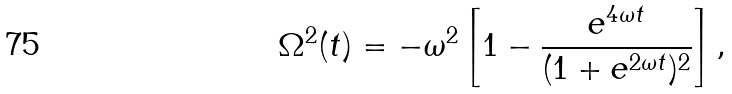<formula> <loc_0><loc_0><loc_500><loc_500>\Omega ^ { 2 } ( t ) = - \omega ^ { 2 } \left [ 1 - \frac { e ^ { 4 \omega t } } { ( 1 + e ^ { 2 \omega t } ) ^ { 2 } } \right ] ,</formula> 